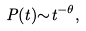Convert formula to latex. <formula><loc_0><loc_0><loc_500><loc_500>P ( t ) { \sim } t ^ { - \theta } ,</formula> 